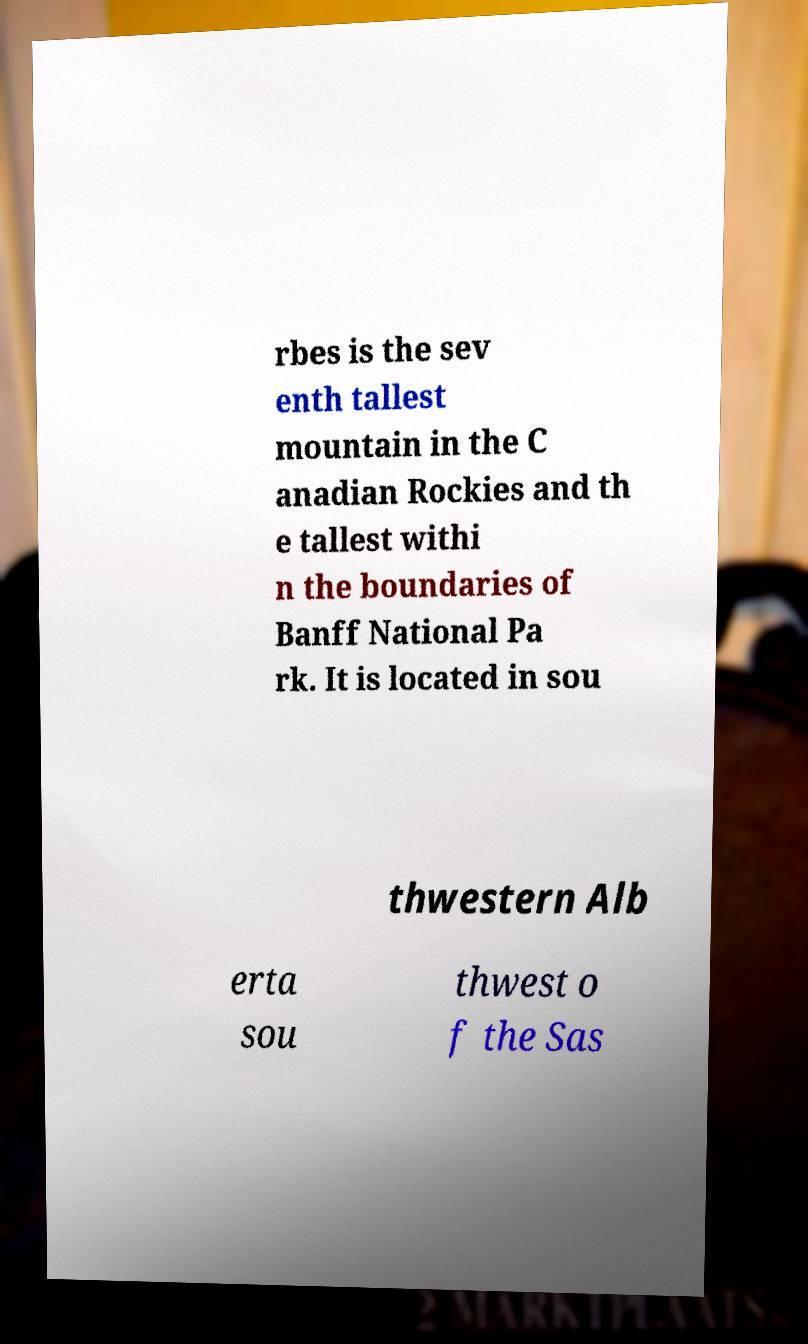Could you extract and type out the text from this image? rbes is the sev enth tallest mountain in the C anadian Rockies and th e tallest withi n the boundaries of Banff National Pa rk. It is located in sou thwestern Alb erta sou thwest o f the Sas 